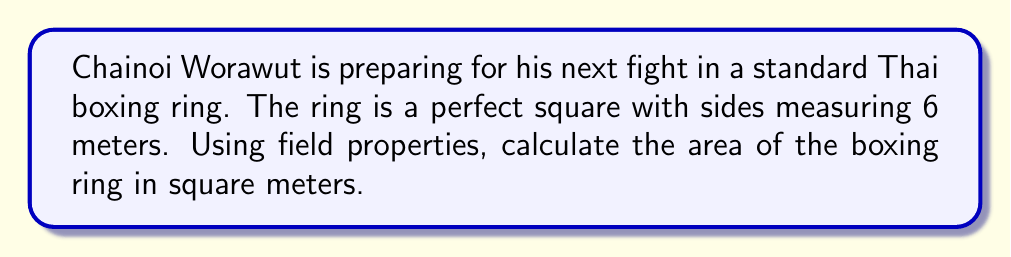Teach me how to tackle this problem. Let's approach this step-by-step using field properties:

1) In field theory, the area of a square is defined as the product of its side length with itself.

2) Let $s$ be the side length of the square boxing ring. We're given that $s = 6$ meters.

3) The area $A$ of the square ring is given by the formula:

   $$A = s \cdot s = s^2$$

4) Substituting the value of $s$:

   $$A = 6^2$$

5) In a field, we can evaluate this power:

   $$A = 6 \cdot 6 = 36$$

6) Therefore, the area of the boxing ring is 36 square meters.

This calculation uses the field property of multiplication, where we can multiply an element (in this case, 6) by itself to get its square.
Answer: $36 \text{ m}^2$ 